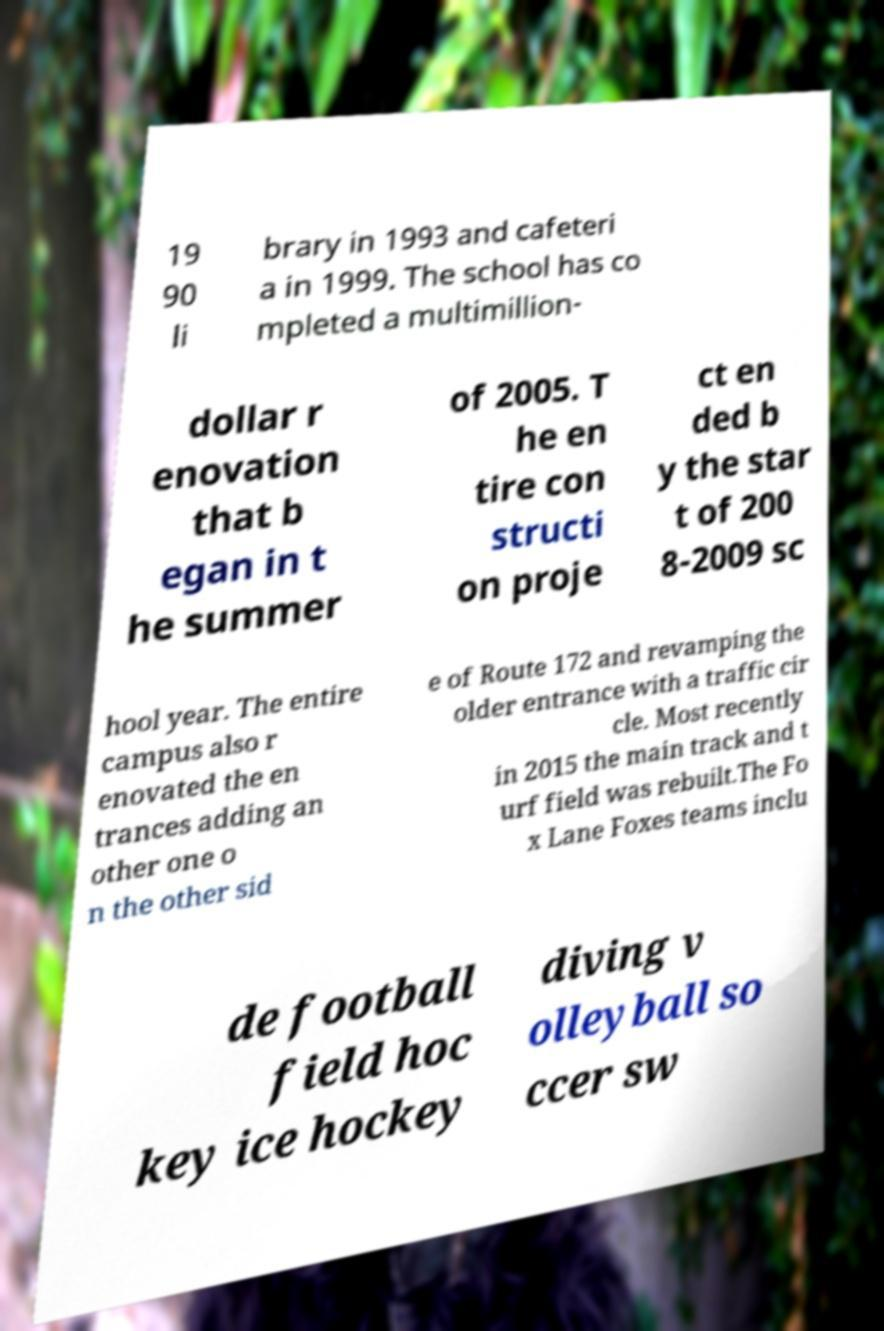Please identify and transcribe the text found in this image. 19 90 li brary in 1993 and cafeteri a in 1999. The school has co mpleted a multimillion- dollar r enovation that b egan in t he summer of 2005. T he en tire con structi on proje ct en ded b y the star t of 200 8-2009 sc hool year. The entire campus also r enovated the en trances adding an other one o n the other sid e of Route 172 and revamping the older entrance with a traffic cir cle. Most recently in 2015 the main track and t urf field was rebuilt.The Fo x Lane Foxes teams inclu de football field hoc key ice hockey diving v olleyball so ccer sw 